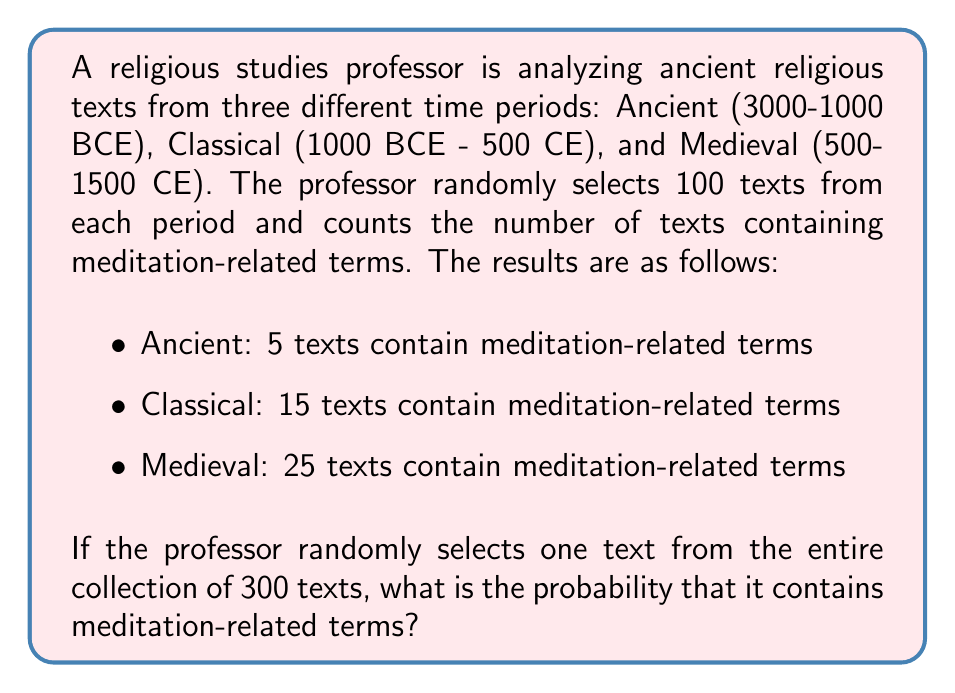Give your solution to this math problem. To solve this problem, we need to follow these steps:

1. Calculate the total number of texts containing meditation-related terms:
   $5 + 15 + 25 = 45$ texts

2. Calculate the total number of texts in the collection:
   $100 + 100 + 100 = 300$ texts

3. Apply the probability formula:
   $$P(\text{meditation terms}) = \frac{\text{Number of favorable outcomes}}{\text{Total number of possible outcomes}}$$

   $$P(\text{meditation terms}) = \frac{45}{300}$$

4. Simplify the fraction:
   $$P(\text{meditation terms}) = \frac{45}{300} = \frac{3}{20} = 0.15$$

Therefore, the probability of randomly selecting a text containing meditation-related terms from the entire collection is $\frac{3}{20}$ or 0.15 or 15%.
Answer: $\frac{3}{20}$ or 0.15 or 15% 